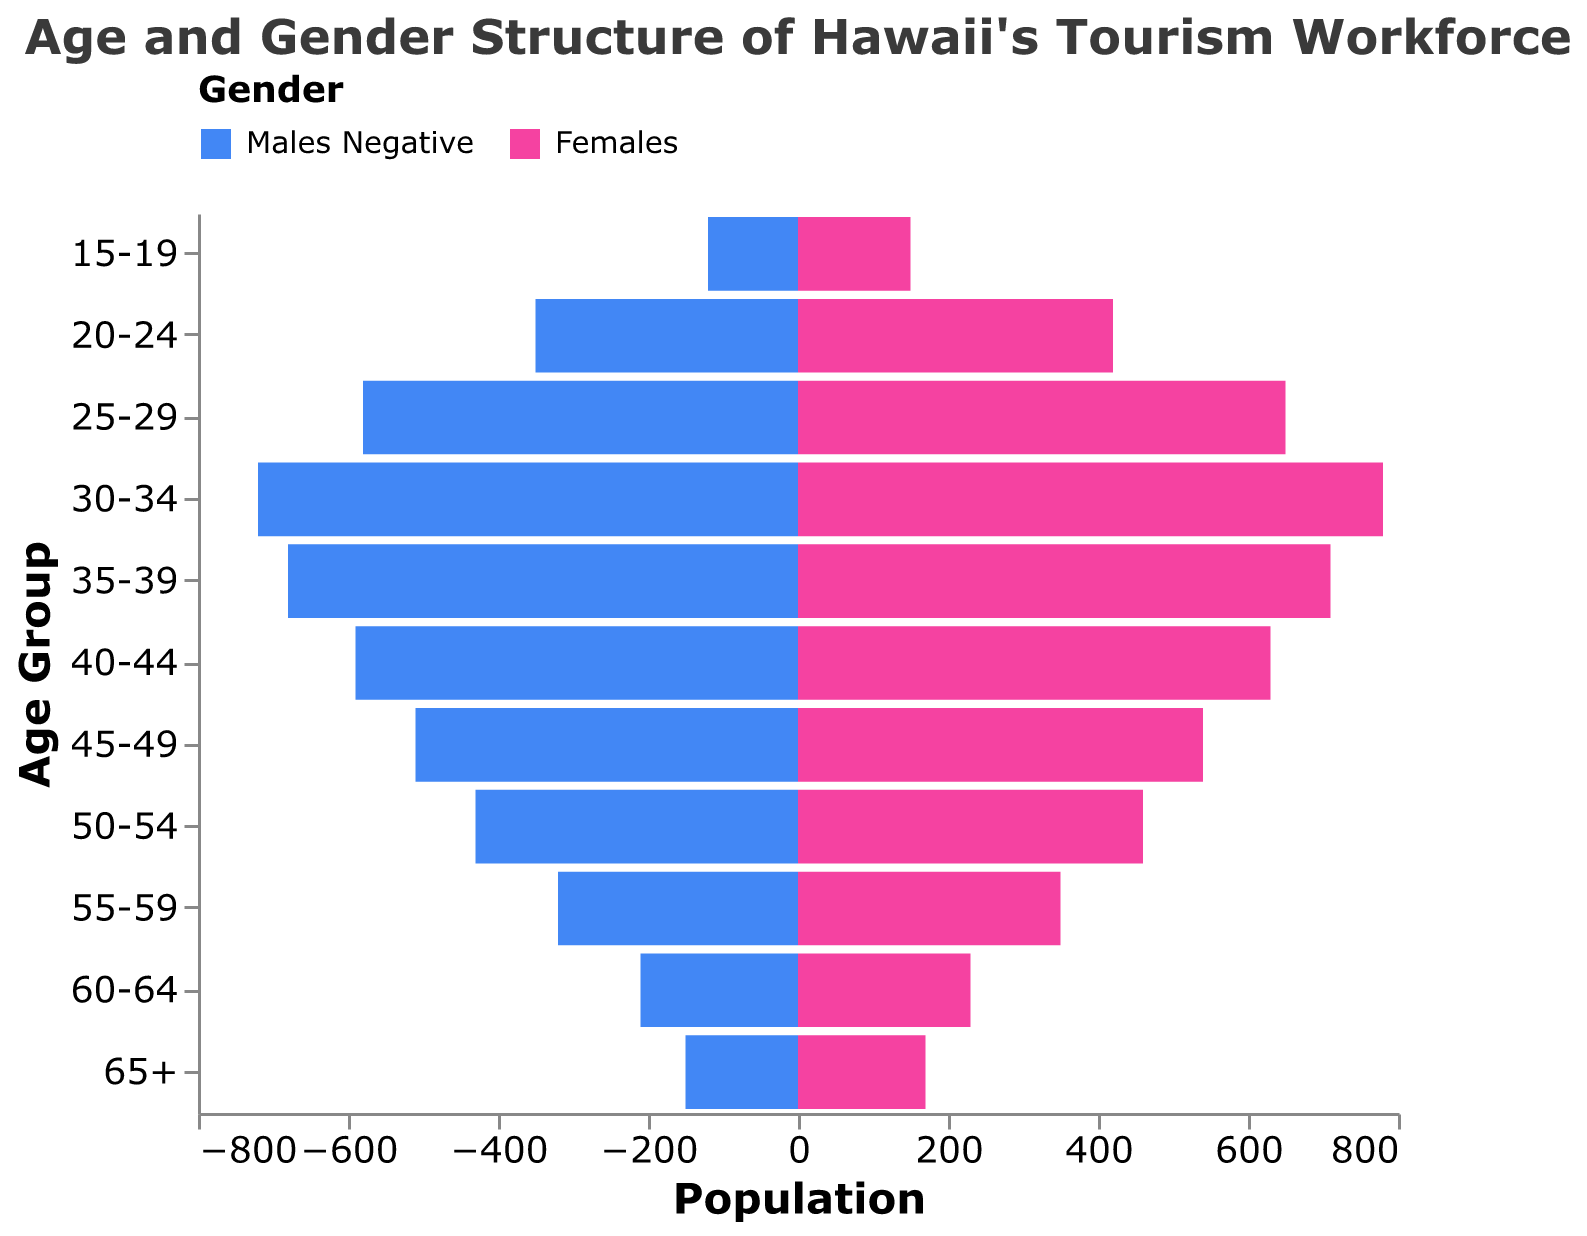What's the total population for the 30-34 age group? Add the number of males (720) and females (780) in the 30-34 age group: 720 + 780 = 1500
Answer: 1500 How many females are in the 45-49 age group? Look at the bar representing females in the 45-49 age group, which shows 540 females.
Answer: 540 Which age group has the smallest number of males? Find the smallest value in the males' data column, which is 120 in the 15-19 age group.
Answer: 15-19 What's the difference in the number of males and females in the 35-39 age group? Subtract the number of males (680) from the number of females (710): 710 - 680 = 30
Answer: 30 What's the gender with the greater number in the 20-24 age group? Compare the number of males (350) and females (420) in the 20-24 age group. Females have a higher number.
Answer: Females Which age group has the highest number of personnel in total? Add the males and females in each age group and identify the age group with the largest sum. The 30-34 age group has the highest total with 720 (males) + 780 (females) = 1500.
Answer: 30-34 What's the population difference between the 25-29 and the 55-59 age groups? Calculate the total population for each age group and find the difference. 25-29: 580 (males) + 650 (females) = 1230. 55-59: 320 (males) + 350 (females) = 670. Difference: 1230 - 670 = 560
Answer: 560 Which age group has more males than females? Identify age groups where the number of males exceeds the number of females. Only the 30-34 age group has more males (720) than females (780).
Answer: None (all groups have more females) How does the population of the 60-64 age group compare to the 65+ age group? Compare the sum of males and females in the 60-64 age group (210 + 230 = 440) to the 65+ age group (150 + 170 = 320).
Answer: The 60-64 age group has a higher population What's the average population of females across all age groups? Sum the number of females in each age group: 150 + 420 + 650 + 780 + 710 + 630 + 540 + 460 + 350 + 230 + 170 = 5090. Divide by the number of age groups (11): 5090 / 11 ≈ 462.73
Answer: 462.73 